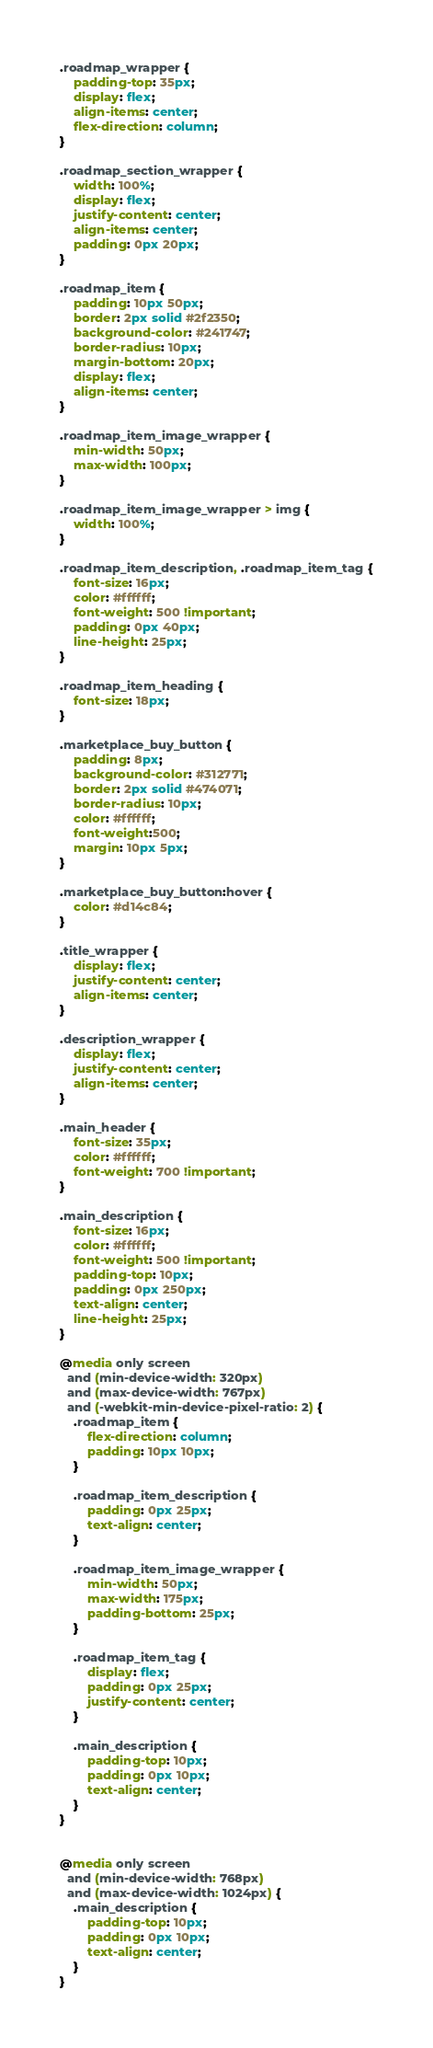<code> <loc_0><loc_0><loc_500><loc_500><_CSS_>.roadmap_wrapper {
    padding-top: 35px;
    display: flex;
    align-items: center;
    flex-direction: column;
}

.roadmap_section_wrapper {
    width: 100%;
    display: flex;
    justify-content: center;
    align-items: center;
    padding: 0px 20px;
}

.roadmap_item {
    padding: 10px 50px;
    border: 2px solid #2f2350;
    background-color: #241747;
    border-radius: 10px;
    margin-bottom: 20px;
    display: flex;
    align-items: center;
}

.roadmap_item_image_wrapper {
    min-width: 50px;
    max-width: 100px;
}

.roadmap_item_image_wrapper > img {
    width: 100%;
}

.roadmap_item_description, .roadmap_item_tag {
    font-size: 16px;
    color: #ffffff;
    font-weight: 500 !important;
    padding: 0px 40px;
    line-height: 25px;
}

.roadmap_item_heading {
    font-size: 18px;
}

.marketplace_buy_button {
    padding: 8px;
    background-color: #312771;
    border: 2px solid #474071;
    border-radius: 10px;
    color: #ffffff;
    font-weight:500;
    margin: 10px 5px;
}

.marketplace_buy_button:hover {
    color: #d14c84;
}

.title_wrapper {
    display: flex;
    justify-content: center;
    align-items: center;
}

.description_wrapper {
    display: flex;
    justify-content: center;
    align-items: center;
}

.main_header {
    font-size: 35px;
    color: #ffffff;
    font-weight: 700 !important;
}

.main_description {
    font-size: 16px;
    color: #ffffff;
    font-weight: 500 !important;
    padding-top: 10px;
    padding: 0px 250px;
    text-align: center;
    line-height: 25px;
}

@media only screen 
  and (min-device-width: 320px) 
  and (max-device-width: 767px)
  and (-webkit-min-device-pixel-ratio: 2) {
    .roadmap_item {
        flex-direction: column;
        padding: 10px 10px;
    }

    .roadmap_item_description {
        padding: 0px 25px;
        text-align: center;
    }

    .roadmap_item_image_wrapper {
        min-width: 50px;
        max-width: 175px;
        padding-bottom: 25px;
    }

    .roadmap_item_tag {
        display: flex;
        padding: 0px 25px;
        justify-content: center;
    }

    .main_description {
        padding-top: 10px;
        padding: 0px 10px;
        text-align: center;
    }
}


@media only screen 
  and (min-device-width: 768px) 
  and (max-device-width: 1024px) {
    .main_description {
        padding-top: 10px;
        padding: 0px 10px;
        text-align: center;
    }
}</code> 